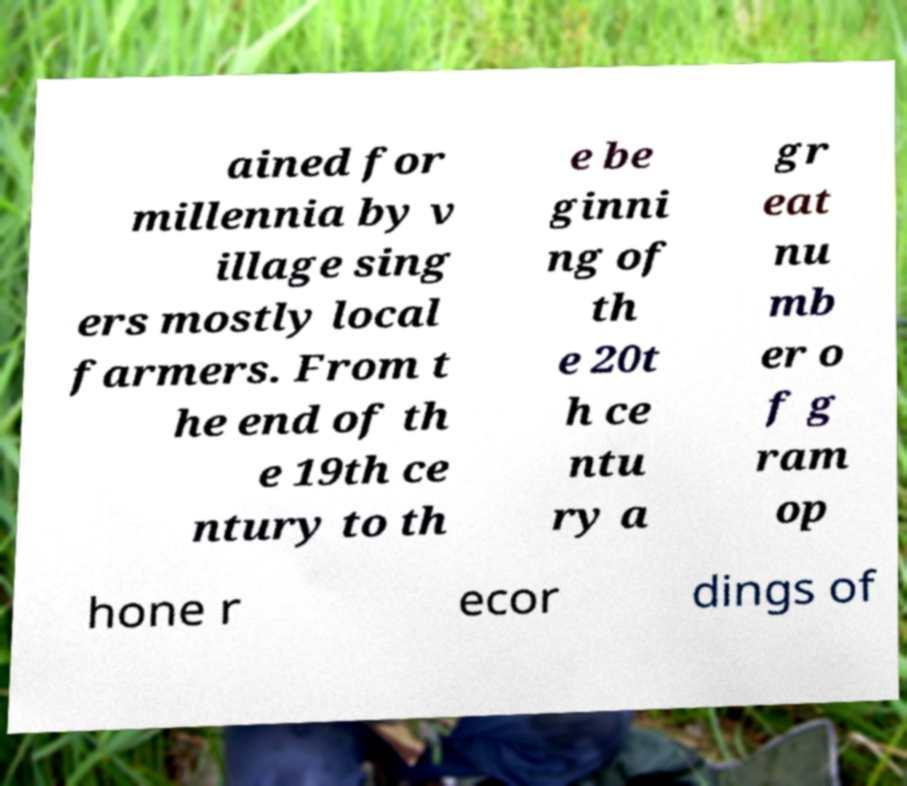I need the written content from this picture converted into text. Can you do that? ained for millennia by v illage sing ers mostly local farmers. From t he end of th e 19th ce ntury to th e be ginni ng of th e 20t h ce ntu ry a gr eat nu mb er o f g ram op hone r ecor dings of 